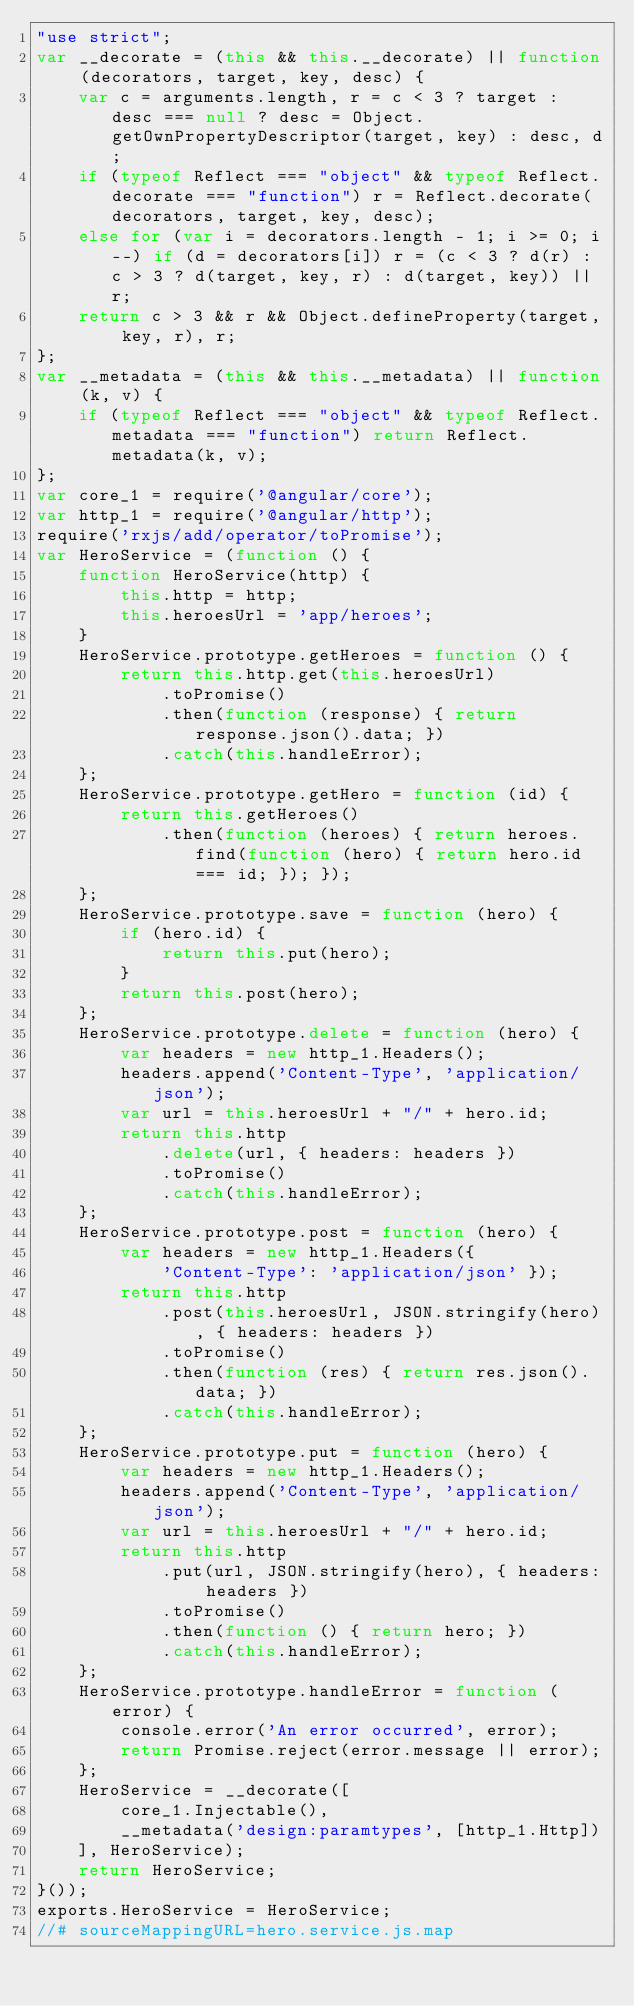Convert code to text. <code><loc_0><loc_0><loc_500><loc_500><_JavaScript_>"use strict";
var __decorate = (this && this.__decorate) || function (decorators, target, key, desc) {
    var c = arguments.length, r = c < 3 ? target : desc === null ? desc = Object.getOwnPropertyDescriptor(target, key) : desc, d;
    if (typeof Reflect === "object" && typeof Reflect.decorate === "function") r = Reflect.decorate(decorators, target, key, desc);
    else for (var i = decorators.length - 1; i >= 0; i--) if (d = decorators[i]) r = (c < 3 ? d(r) : c > 3 ? d(target, key, r) : d(target, key)) || r;
    return c > 3 && r && Object.defineProperty(target, key, r), r;
};
var __metadata = (this && this.__metadata) || function (k, v) {
    if (typeof Reflect === "object" && typeof Reflect.metadata === "function") return Reflect.metadata(k, v);
};
var core_1 = require('@angular/core');
var http_1 = require('@angular/http');
require('rxjs/add/operator/toPromise');
var HeroService = (function () {
    function HeroService(http) {
        this.http = http;
        this.heroesUrl = 'app/heroes';
    }
    HeroService.prototype.getHeroes = function () {
        return this.http.get(this.heroesUrl)
            .toPromise()
            .then(function (response) { return response.json().data; })
            .catch(this.handleError);
    };
    HeroService.prototype.getHero = function (id) {
        return this.getHeroes()
            .then(function (heroes) { return heroes.find(function (hero) { return hero.id === id; }); });
    };
    HeroService.prototype.save = function (hero) {
        if (hero.id) {
            return this.put(hero);
        }
        return this.post(hero);
    };
    HeroService.prototype.delete = function (hero) {
        var headers = new http_1.Headers();
        headers.append('Content-Type', 'application/json');
        var url = this.heroesUrl + "/" + hero.id;
        return this.http
            .delete(url, { headers: headers })
            .toPromise()
            .catch(this.handleError);
    };
    HeroService.prototype.post = function (hero) {
        var headers = new http_1.Headers({
            'Content-Type': 'application/json' });
        return this.http
            .post(this.heroesUrl, JSON.stringify(hero), { headers: headers })
            .toPromise()
            .then(function (res) { return res.json().data; })
            .catch(this.handleError);
    };
    HeroService.prototype.put = function (hero) {
        var headers = new http_1.Headers();
        headers.append('Content-Type', 'application/json');
        var url = this.heroesUrl + "/" + hero.id;
        return this.http
            .put(url, JSON.stringify(hero), { headers: headers })
            .toPromise()
            .then(function () { return hero; })
            .catch(this.handleError);
    };
    HeroService.prototype.handleError = function (error) {
        console.error('An error occurred', error);
        return Promise.reject(error.message || error);
    };
    HeroService = __decorate([
        core_1.Injectable(), 
        __metadata('design:paramtypes', [http_1.Http])
    ], HeroService);
    return HeroService;
}());
exports.HeroService = HeroService;
//# sourceMappingURL=hero.service.js.map</code> 